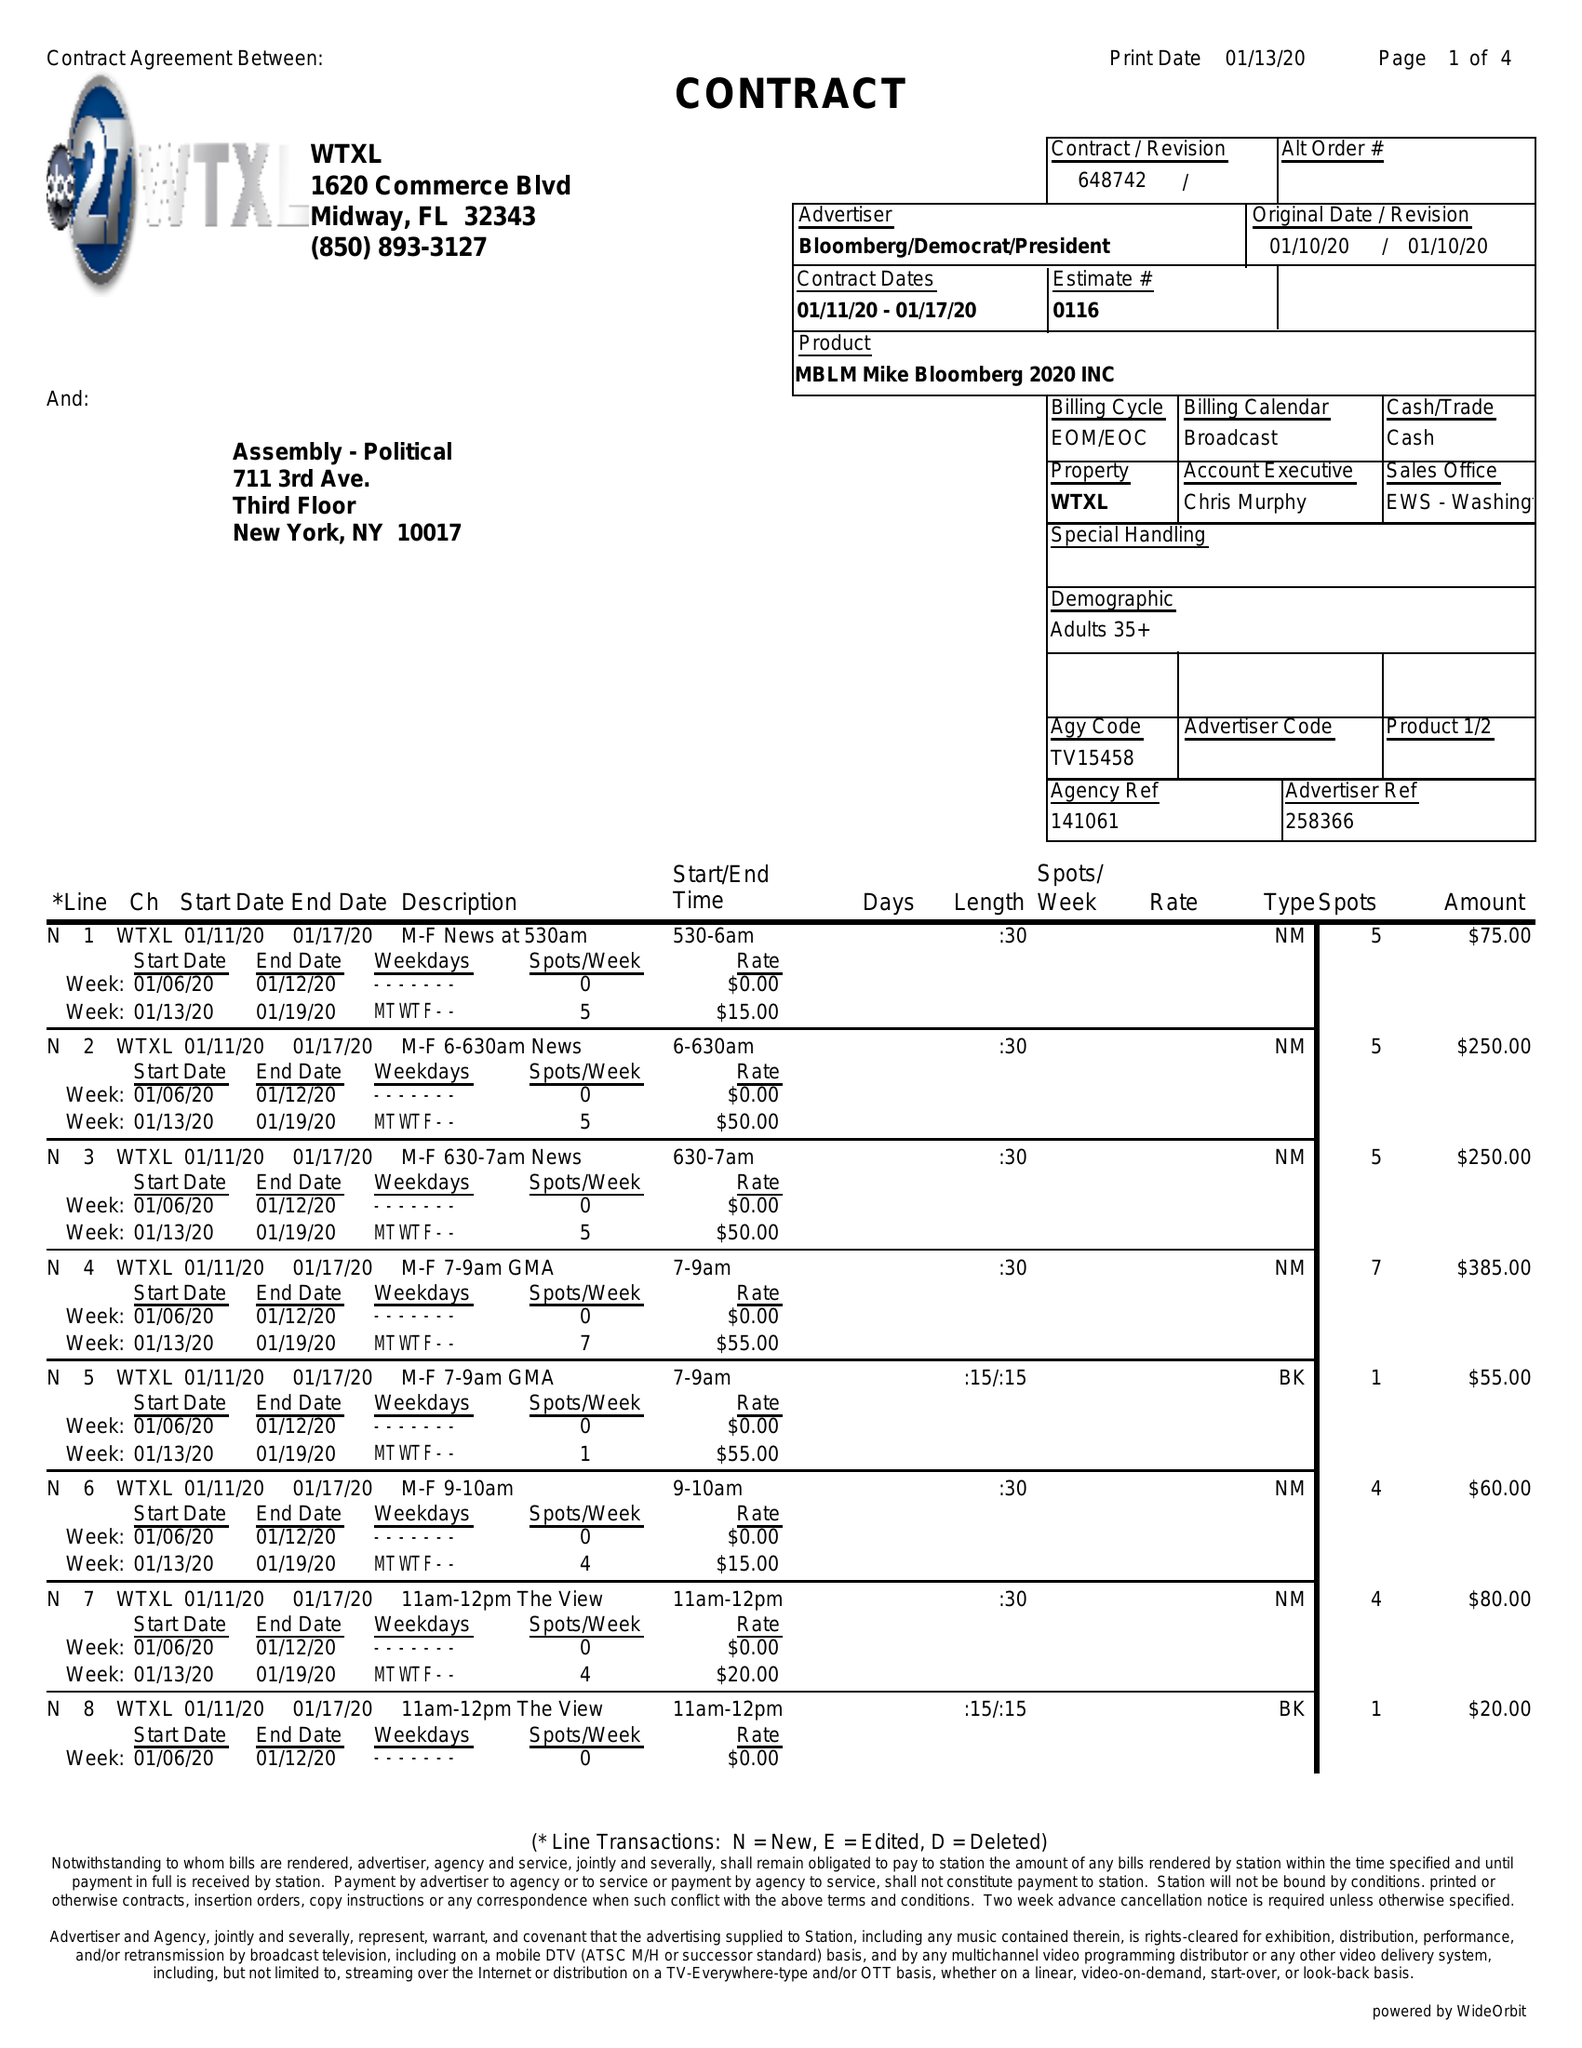What is the value for the flight_to?
Answer the question using a single word or phrase. 01/17/20 